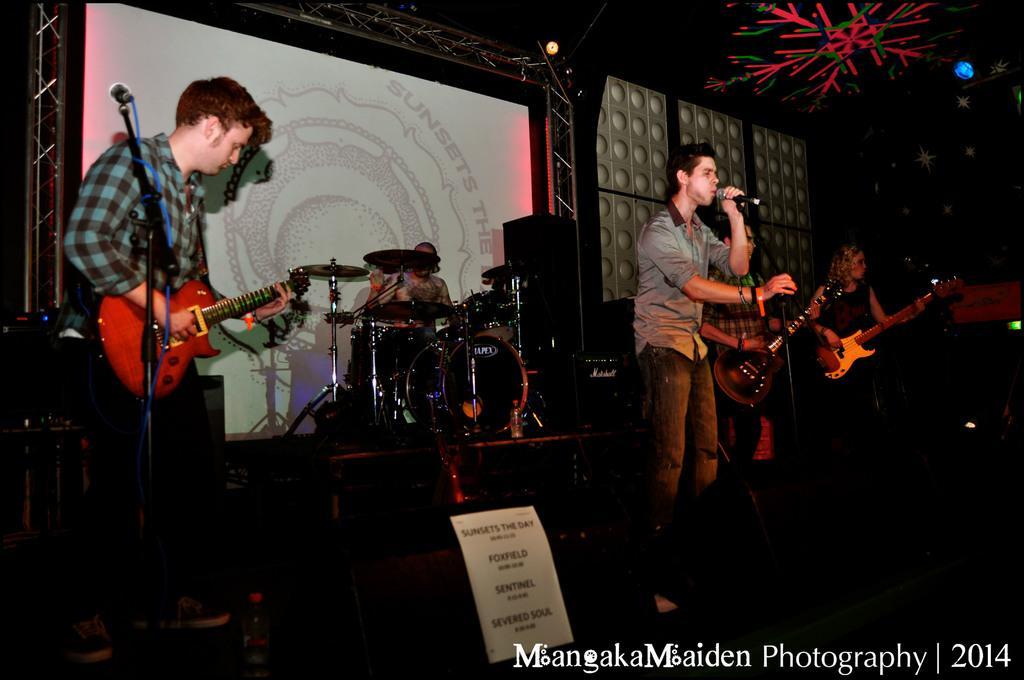Could you give a brief overview of what you see in this image? In the image few people are holding some musical instruments and this person holding a microphone. Behind them there is a screen. At the top of the image there is roof. At the bottom of the image there is a poster and water bottle. 